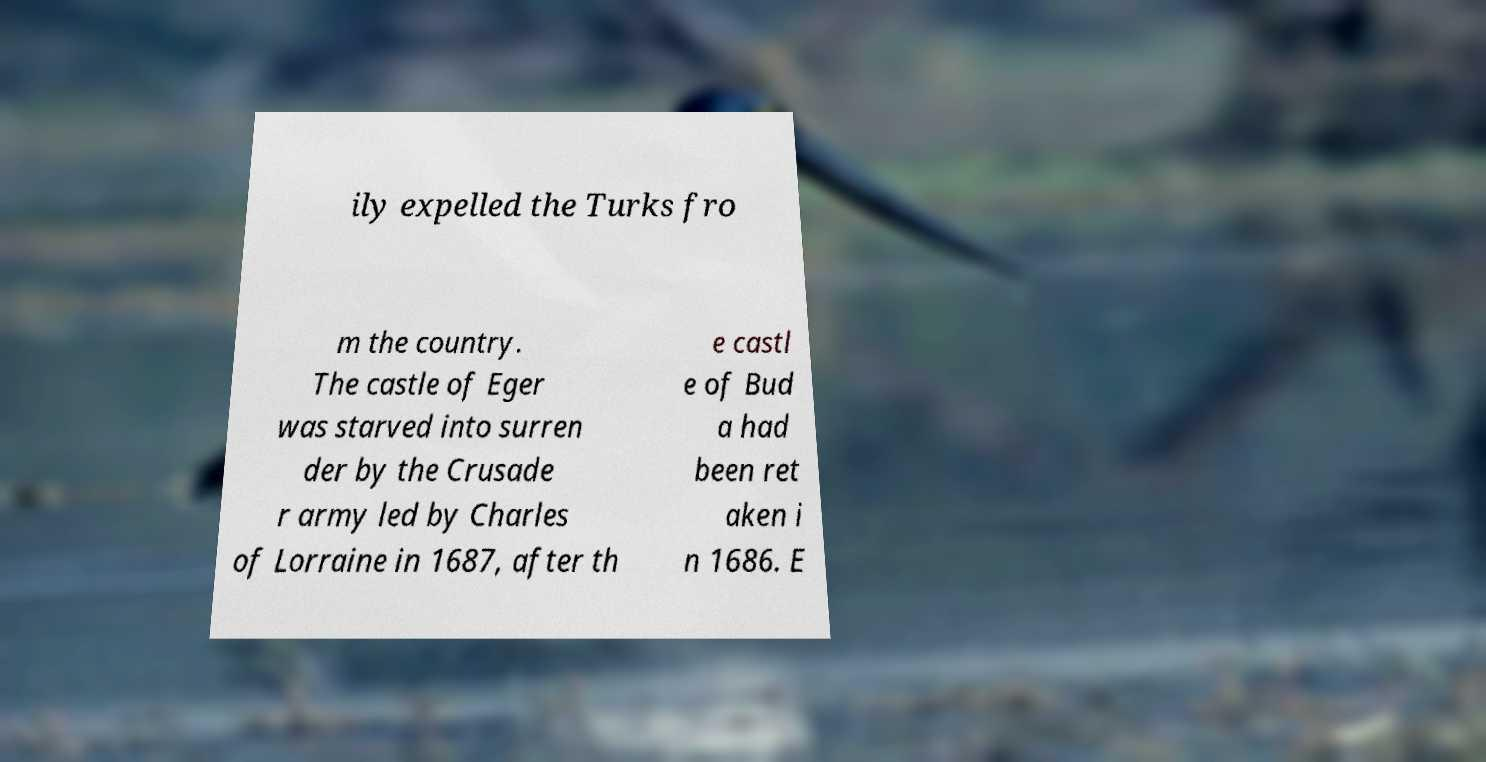Could you extract and type out the text from this image? ily expelled the Turks fro m the country. The castle of Eger was starved into surren der by the Crusade r army led by Charles of Lorraine in 1687, after th e castl e of Bud a had been ret aken i n 1686. E 